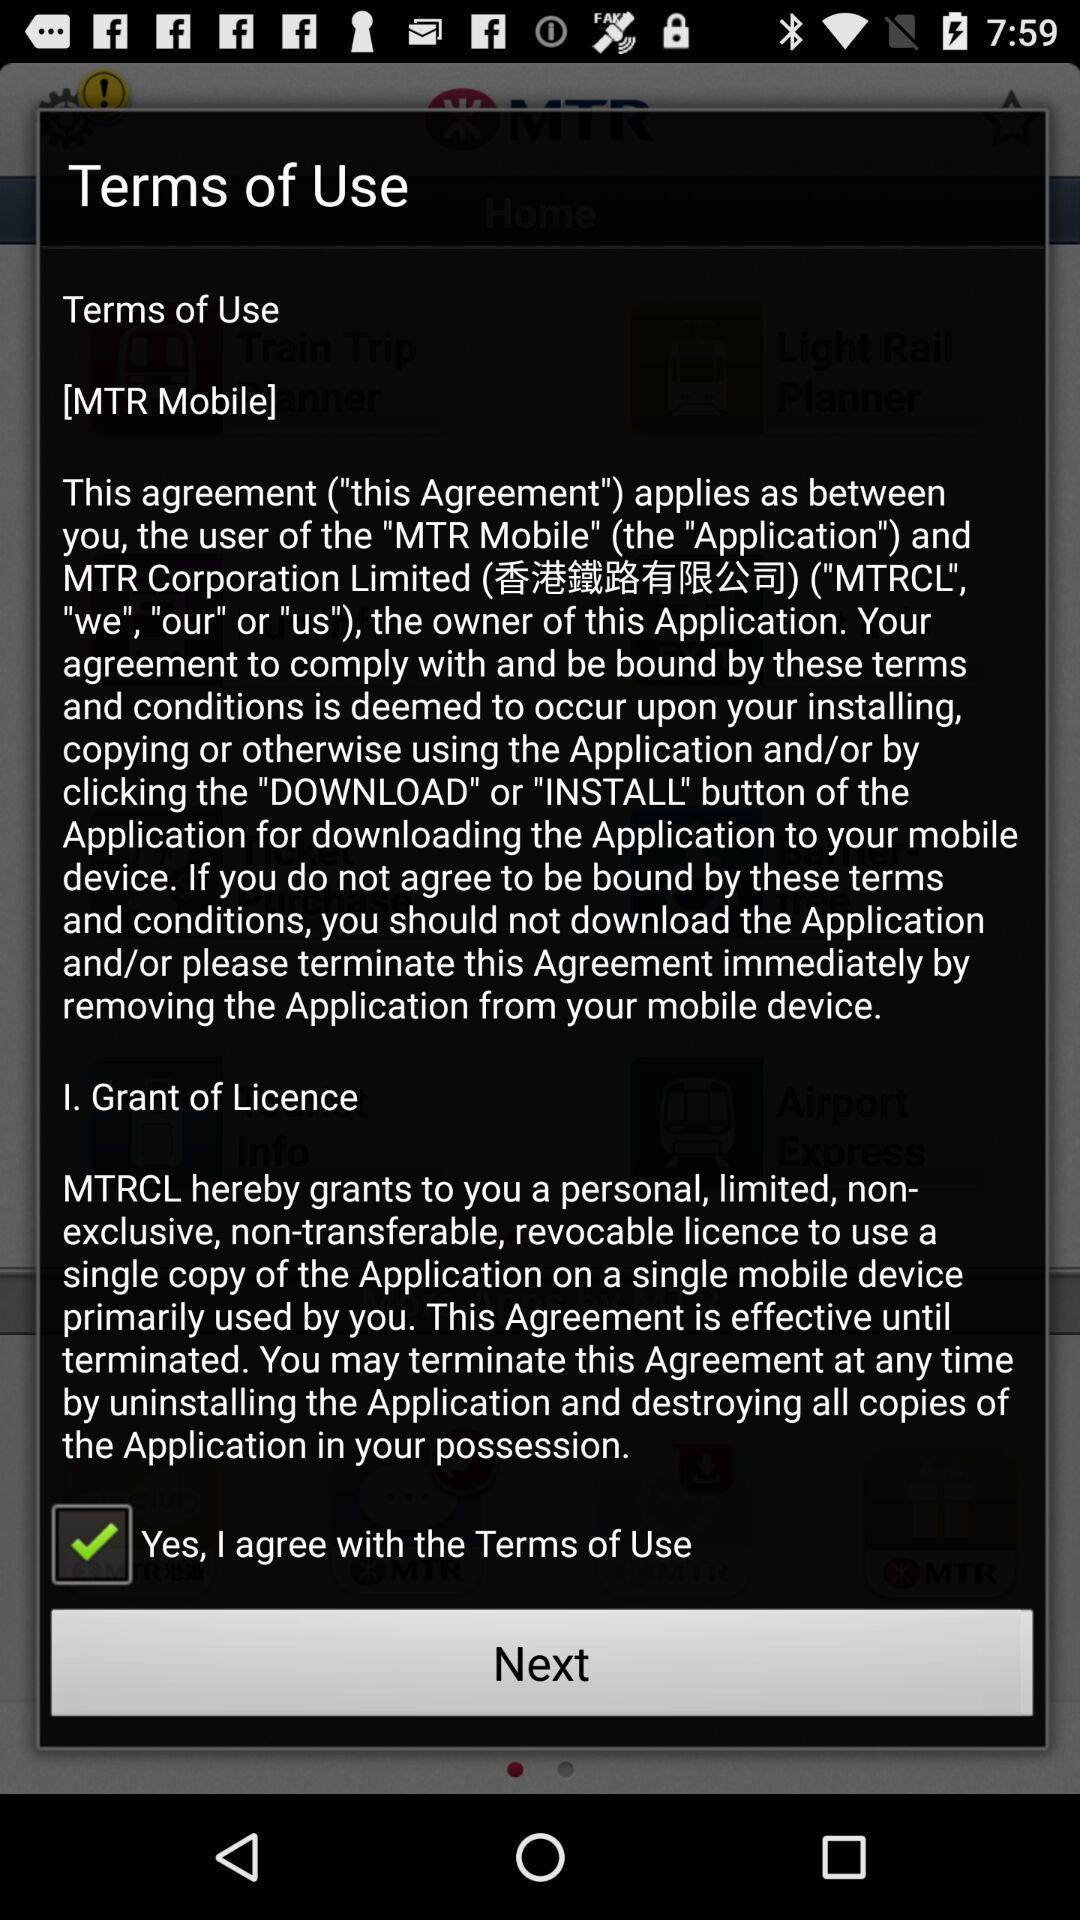What is the status of "Yes, I agree with the Terms of Use"? The status is "on". 